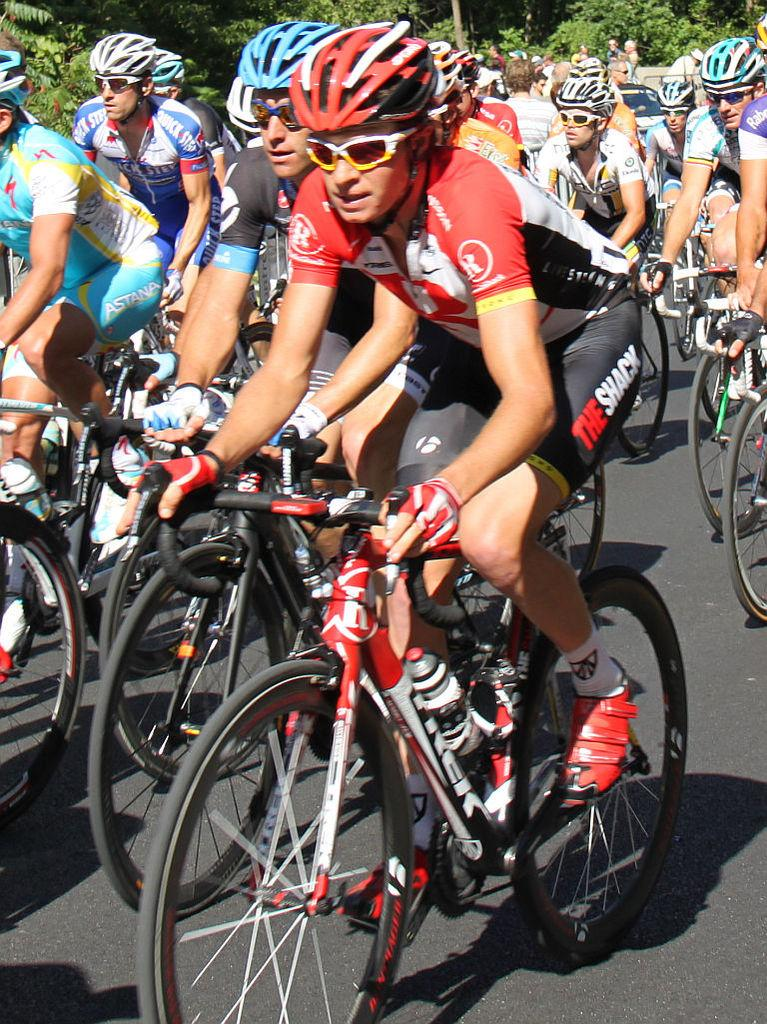What are the people in the image doing? The people in the image are riding bicycles. What are the people wearing while riding bicycles? The people are wearing helmets. Where are the people riding their bicycles? The bicycles are on a road. What can be seen in the background of the image? There is a group of trees visible in the background. What type of steel is used to make the bicycles in the image? There is no information about the type of steel used to make the bicycles in the image. Additionally, the material used to make the bicycles is not visible in the image. 